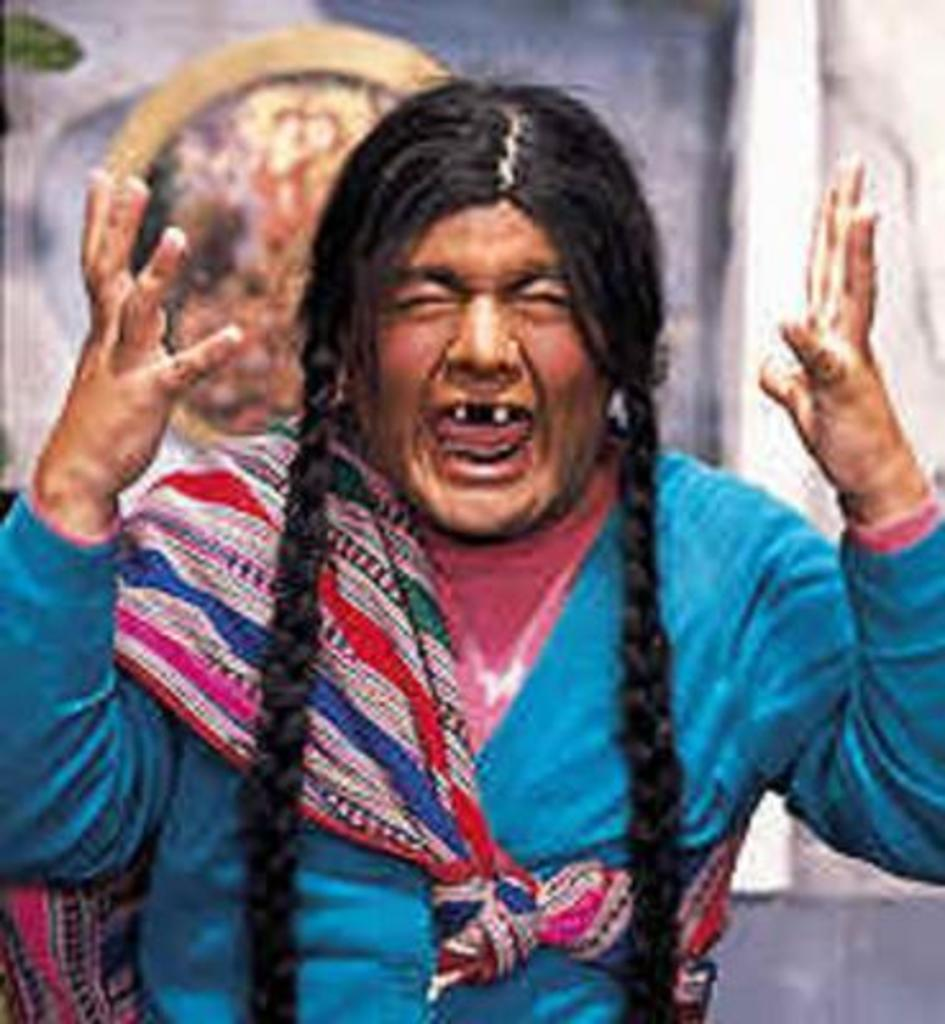What is present in the image? There is a person in the image. Can you describe the person's attire? The person is wearing a blue and pink color dress. How would you describe the background of the image? The background of the image is blurred. How many boots can be seen in the image? There are no boots present in the image. What type of air is visible in the image? There is no air visible in the image, as it is a two-dimensional representation. 